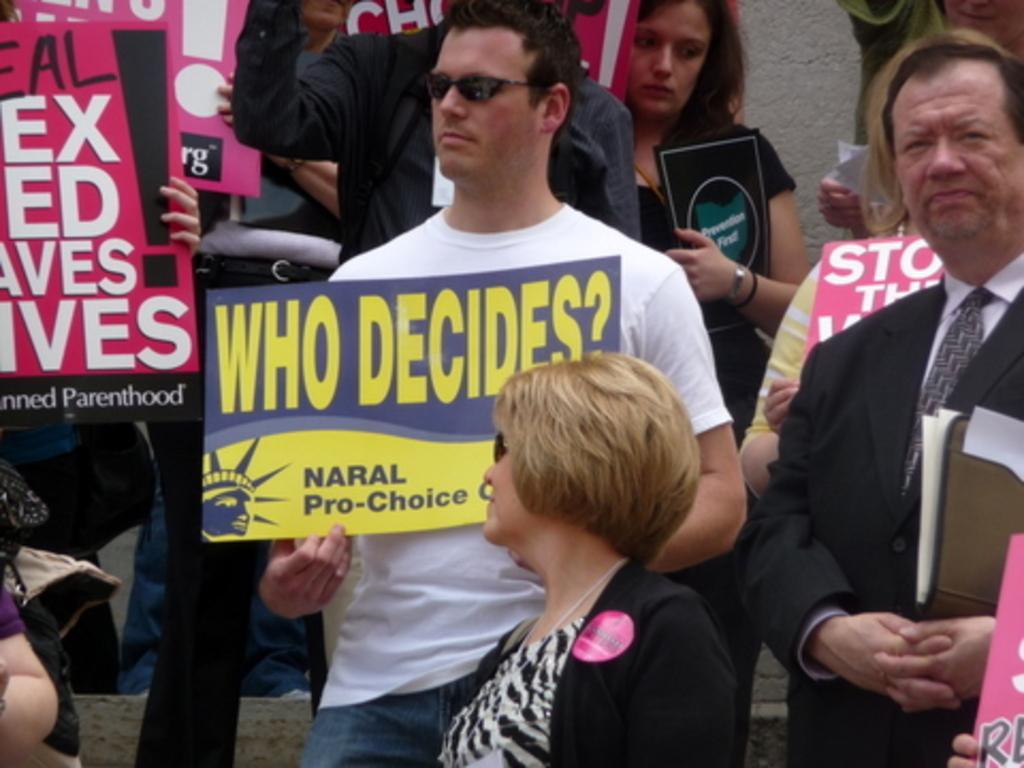In one or two sentences, can you explain what this image depicts? In this image I can see the group of people with different color dresses. I can see few people are holding the boards and one person is holding the file. 